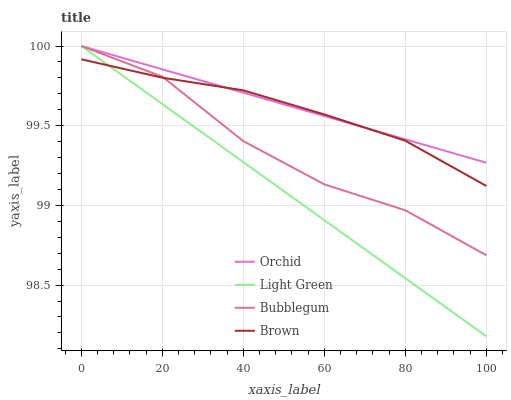Does Bubblegum have the minimum area under the curve?
Answer yes or no. No. Does Bubblegum have the maximum area under the curve?
Answer yes or no. No. Is Light Green the smoothest?
Answer yes or no. No. Is Light Green the roughest?
Answer yes or no. No. Does Bubblegum have the lowest value?
Answer yes or no. No. 